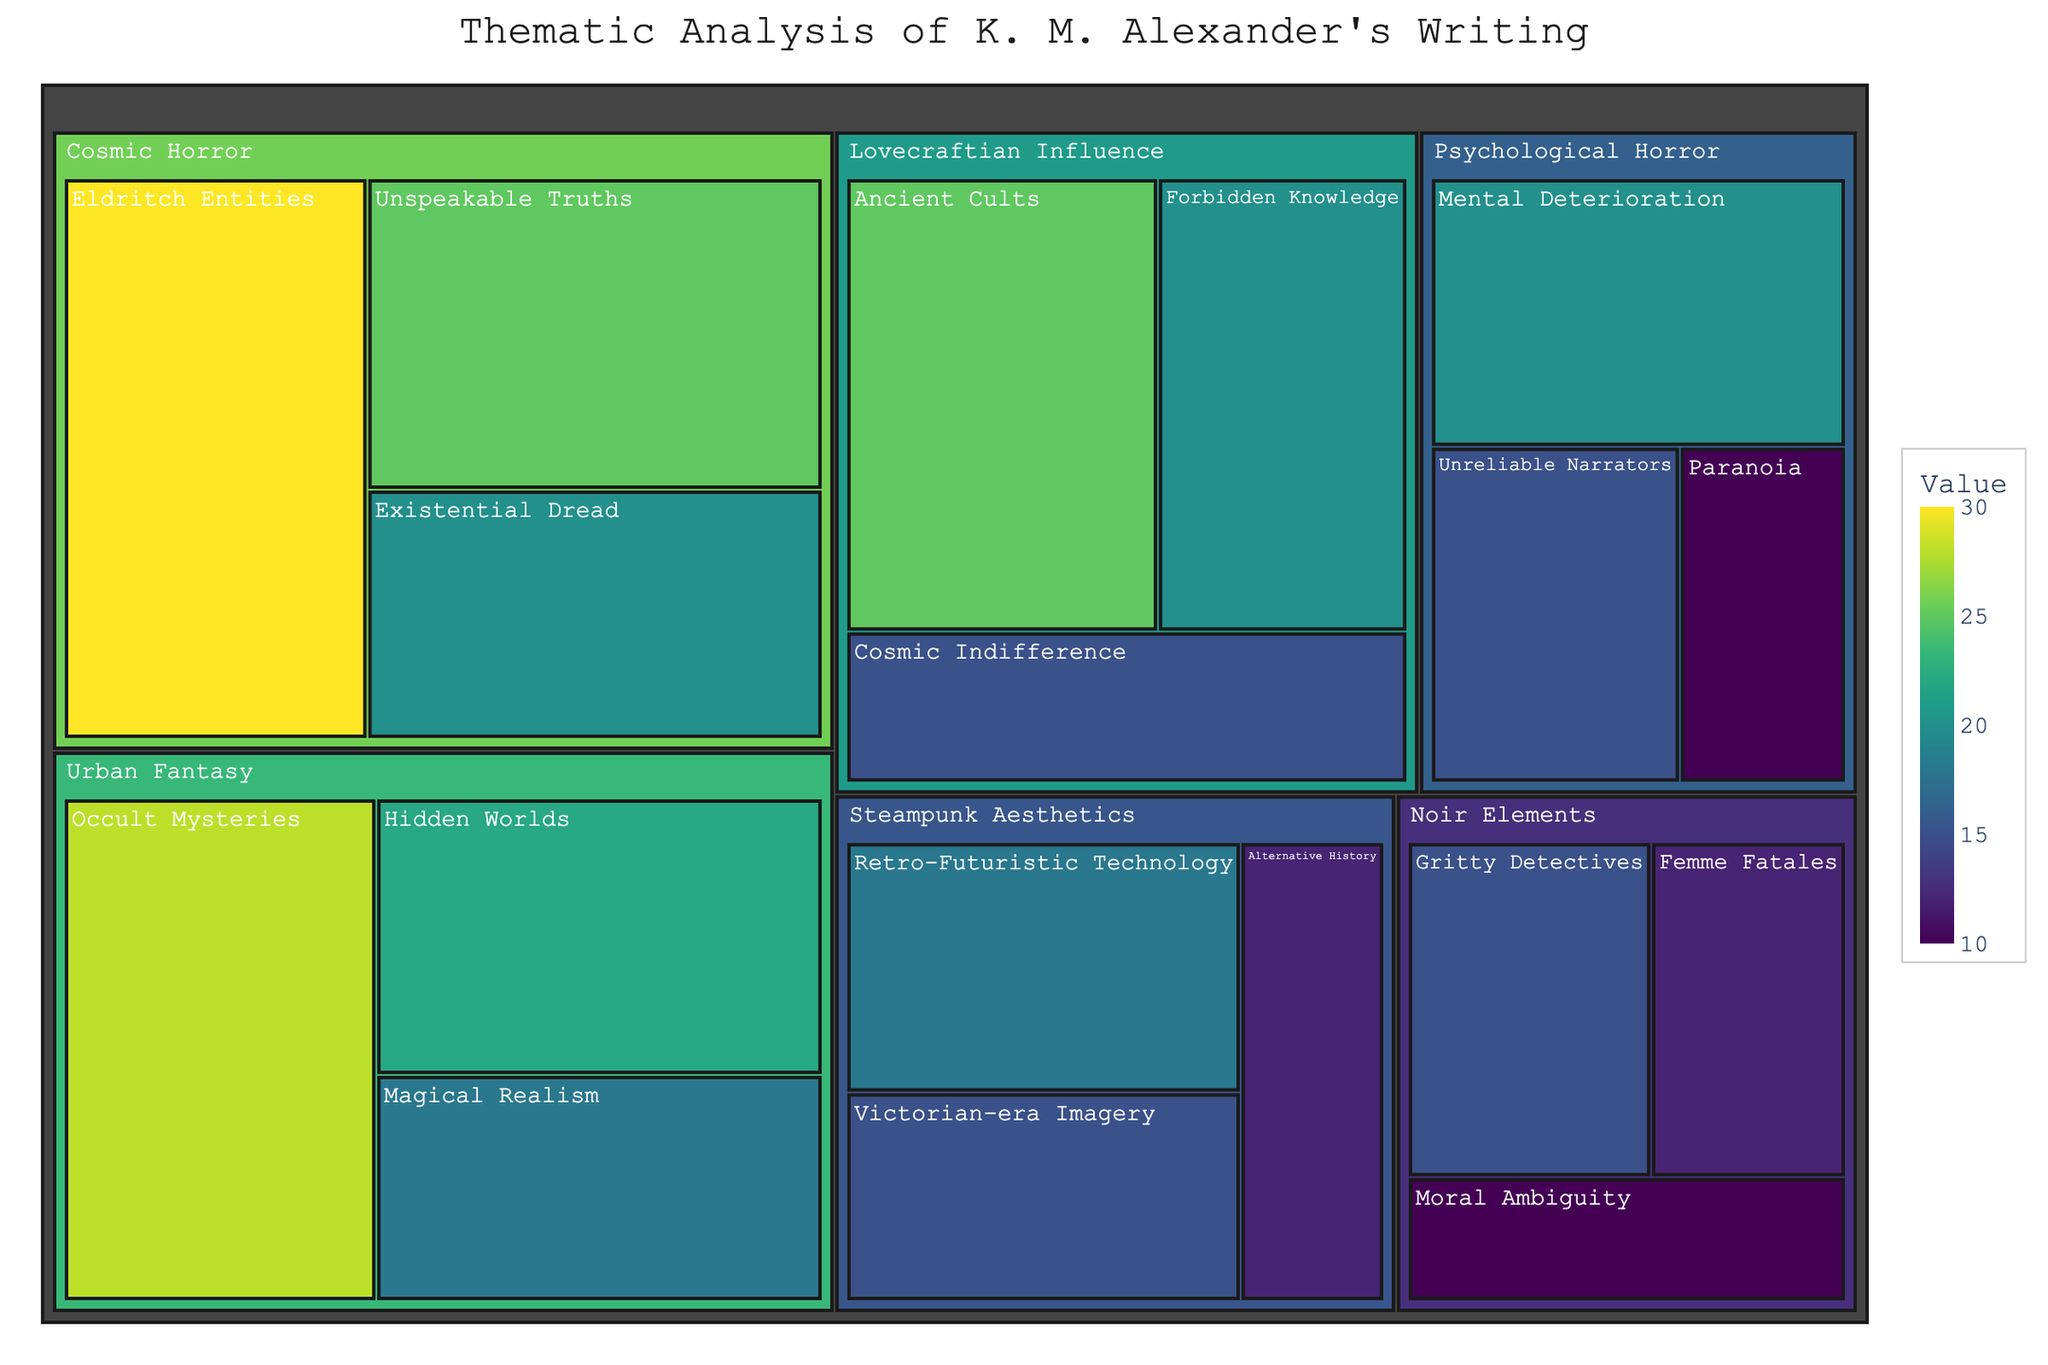What's the title of the treemap? The title of the treemap is typically displayed prominently at the top of the chart. In the given data, it is specified in the code as "Thematic Analysis of K. M. Alexander's Writing"
Answer: Thematic Analysis of K. M. Alexander's Writing How many major themes are there? The major themes can be identified as the first level of categorization in the treemap. According to the data provided, there are five major themes: "Cosmic Horror," "Urban Fantasy," "Noir Elements," "Lovecraftian Influence," and "Steampunk Aesthetics."
Answer: 5 Which subtheme has the highest value? To determine the subtheme with the highest value, we look for the subtheme with the largest numerical value in the data. "Eldritch Entities" under the theme "Cosmic Horror" has the highest value of 30.
Answer: Eldritch Entities Sum the values of all subthemes under "Urban Fantasy." Adding up the values of subthemes under "Urban Fantasy" gives the total: 28 (Occult Mysteries) + 22 (Hidden Worlds) + 18 (Magical Realism) = 68
Answer: 68 Compare the total value of "Cosmic Horror" to "Lovecraftian Influence." Which is greater, and by how much? The total value for "Cosmic Horror" is 30 (Eldritch Entities) + 25 (Unspeakable Truths) + 20 (Existential Dread) = 75. The total value for "Lovecraftian Influence" is 25 (Ancient Cults) + 20 (Forbidden Knowledge) + 15 (Cosmic Indifference) = 60. "Cosmic Horror" is greater by 75 - 60 = 15.
Answer: Cosmic Horror by 15 What is the average value of subthemes under "Psychological Horror"? The average value is calculated by adding up the values of subthemes under "Psychological Horror": 20 (Mental Deterioration) + 15 (Unreliable Narrators) + 10 (Paranoia) = 45, and then dividing by the number of subthemes, which is 3. Therefore, the average value is 45/3 = 15.
Answer: 15 Which theme has the lowest cumulative value, and what is that value? To find the theme with the lowest cumulative value, sum up the values of subthemes for each theme and compare. "Noir Elements": 15 + 12 + 10 = 37, "Steampunk Aesthetics": 18 + 15 + 12 = 45, etc. "Noir Elements" has the lowest cumulative value of 37.
Answer: Noir Elements, 37 How do the values of "Cosmic Indifference" and "Retro-Futuristic Technology" compare? By directly comparing the values: "Cosmic Indifference" (15) and "Retro-Futuristic Technology" (18), we see that "Retro-Futuristic Technology" is greater than "Cosmic Indifference."
Answer: Retro-Futuristic Technology is greater What's the total value of all subthemes combined? Summing all the subthemes: (30+25+20) + (28+22+18) + (15+12+10) + (25+20+15) + (18+15+12) + (20+15+10) = 262. The total value of all subthemes is 262.
Answer: 262 